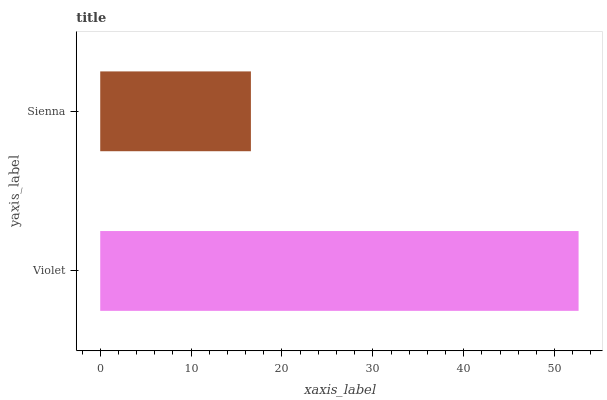Is Sienna the minimum?
Answer yes or no. Yes. Is Violet the maximum?
Answer yes or no. Yes. Is Sienna the maximum?
Answer yes or no. No. Is Violet greater than Sienna?
Answer yes or no. Yes. Is Sienna less than Violet?
Answer yes or no. Yes. Is Sienna greater than Violet?
Answer yes or no. No. Is Violet less than Sienna?
Answer yes or no. No. Is Violet the high median?
Answer yes or no. Yes. Is Sienna the low median?
Answer yes or no. Yes. Is Sienna the high median?
Answer yes or no. No. Is Violet the low median?
Answer yes or no. No. 